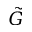<formula> <loc_0><loc_0><loc_500><loc_500>\tilde { G }</formula> 